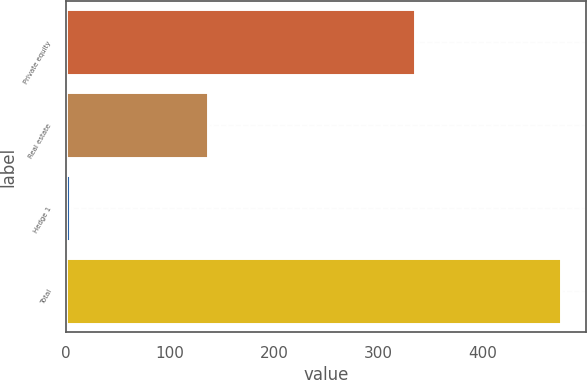Convert chart. <chart><loc_0><loc_0><loc_500><loc_500><bar_chart><fcel>Private equity<fcel>Real estate<fcel>Hedge 1<fcel>Total<nl><fcel>335<fcel>136<fcel>4<fcel>475<nl></chart> 